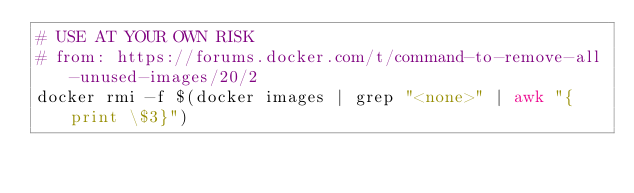<code> <loc_0><loc_0><loc_500><loc_500><_Bash_># USE AT YOUR OWN RISK
# from: https://forums.docker.com/t/command-to-remove-all-unused-images/20/2
docker rmi -f $(docker images | grep "<none>" | awk "{print \$3}")</code> 